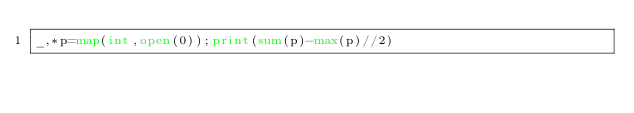<code> <loc_0><loc_0><loc_500><loc_500><_Python_>_,*p=map(int,open(0));print(sum(p)-max(p)//2)</code> 